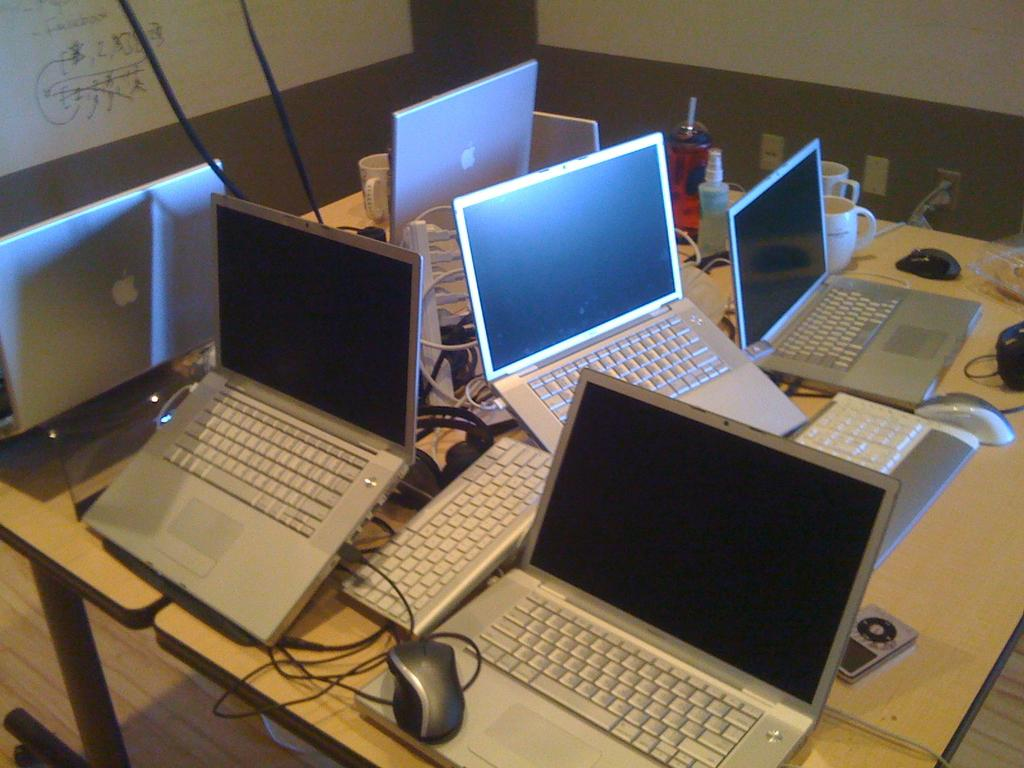What type of electronic devices can be seen in the image? There are laptops in the image. What are the laptops connected to? Mice are connected to the laptops, and cables are visible in the image. What type of containers are present in the image? There are cups and bottles in the image. Where are the laptops, mice, cables, cups, and bottles located? The objects are on a table. What can be seen in the background of the image? There is a board in the background of the image. How many crows are sitting on the floor in the image? There are no crows present in the image; it features laptops, mice, cables, cups, bottles, and a board. What type of lumber is used to construct the table in the image? The type of lumber used to construct the table is not visible or mentioned in the image. 